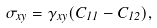<formula> <loc_0><loc_0><loc_500><loc_500>\sigma _ { x y } = \gamma _ { x y } ( C _ { 1 1 } - C _ { 1 2 } ) ,</formula> 